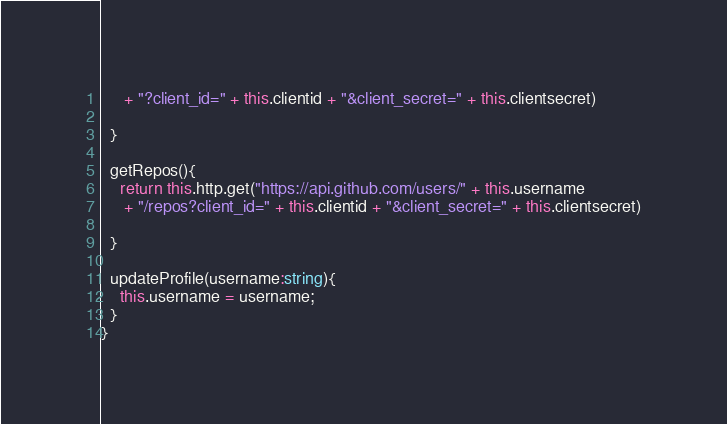Convert code to text. <code><loc_0><loc_0><loc_500><loc_500><_TypeScript_>     + "?client_id=" + this.clientid + "&client_secret=" + this.clientsecret)
     
  }

  getRepos(){
    return this.http.get("https://api.github.com/users/" + this.username
     + "/repos?client_id=" + this.clientid + "&client_secret=" + this.clientsecret)
   
  }

  updateProfile(username:string){
    this.username = username;
  }
}
</code> 